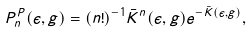<formula> <loc_0><loc_0><loc_500><loc_500>P _ { n } ^ { P } ( \epsilon , g ) = ( n ! ) ^ { - 1 } \bar { K } ^ { n } ( \epsilon , g ) e ^ { - \bar { K } ( \epsilon , g ) } ,</formula> 